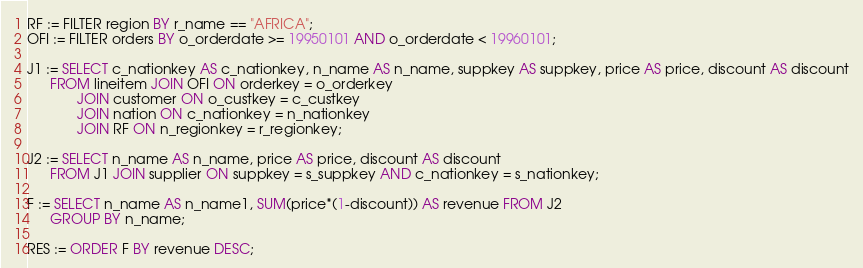<code> <loc_0><loc_0><loc_500><loc_500><_SQL_>RF := FILTER region BY r_name == "AFRICA";
OFI := FILTER orders BY o_orderdate >= 19950101 AND o_orderdate < 19960101;
			 
J1 := SELECT c_nationkey AS c_nationkey, n_name AS n_name, suppkey AS suppkey, price AS price, discount AS discount
      FROM lineitem JOIN OFI ON orderkey = o_orderkey
             JOIN customer ON o_custkey = c_custkey
             JOIN nation ON c_nationkey = n_nationkey
	         JOIN RF ON n_regionkey = r_regionkey;
			 
J2 := SELECT n_name AS n_name, price AS price, discount AS discount
      FROM J1 JOIN supplier ON suppkey = s_suppkey AND c_nationkey = s_nationkey;

F := SELECT n_name AS n_name1, SUM(price*(1-discount)) AS revenue FROM J2
      GROUP BY n_name;
	  
RES := ORDER F BY revenue DESC;	  
</code> 